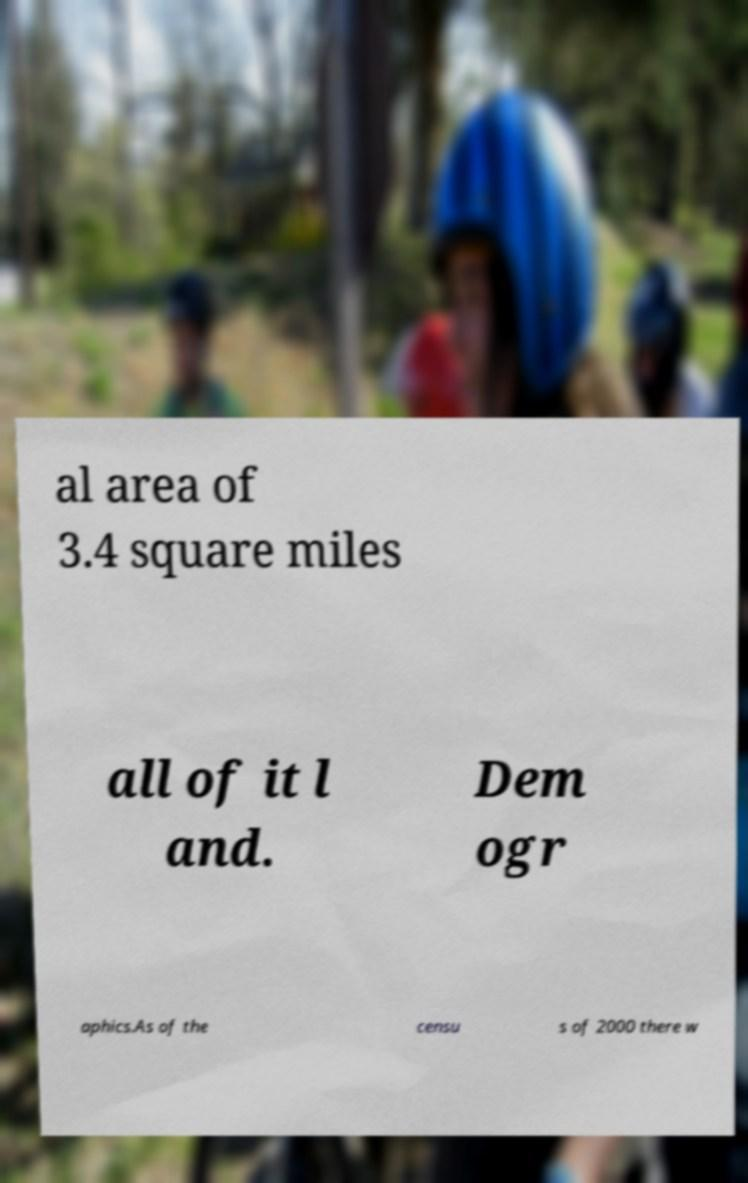There's text embedded in this image that I need extracted. Can you transcribe it verbatim? al area of 3.4 square miles all of it l and. Dem ogr aphics.As of the censu s of 2000 there w 